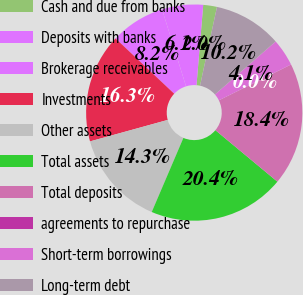Convert chart. <chart><loc_0><loc_0><loc_500><loc_500><pie_chart><fcel>Cash and due from banks<fcel>Deposits with banks<fcel>Brokerage receivables<fcel>Investments<fcel>Other assets<fcel>Total assets<fcel>Total deposits<fcel>agreements to repurchase<fcel>Short-term borrowings<fcel>Long-term debt<nl><fcel>2.05%<fcel>6.13%<fcel>8.17%<fcel>16.32%<fcel>14.28%<fcel>20.4%<fcel>18.36%<fcel>0.01%<fcel>4.09%<fcel>10.2%<nl></chart> 